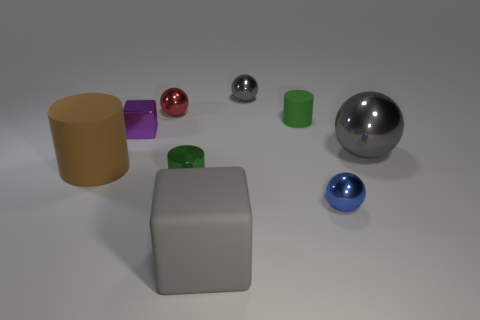There is a cylinder that is in front of the large matte cylinder; what is its color?
Your answer should be very brief. Green. Is the number of gray objects left of the small rubber cylinder greater than the number of big brown cylinders?
Your answer should be very brief. Yes. Do the gray thing on the right side of the tiny gray object and the small gray object have the same shape?
Keep it short and to the point. Yes. How many yellow things are small spheres or small metallic blocks?
Make the answer very short. 0. Are there more red metal objects than small red metallic cylinders?
Provide a succinct answer. Yes. There is a rubber object that is the same size as the green metal object; what color is it?
Your answer should be compact. Green. What number of blocks are either big purple matte objects or brown objects?
Make the answer very short. 0. There is a tiny red metal object; does it have the same shape as the big gray object that is behind the big matte block?
Your answer should be compact. Yes. How many green balls have the same size as the purple shiny object?
Give a very brief answer. 0. Do the green thing that is behind the tiny purple object and the large metal object behind the big cube have the same shape?
Offer a very short reply. No. 